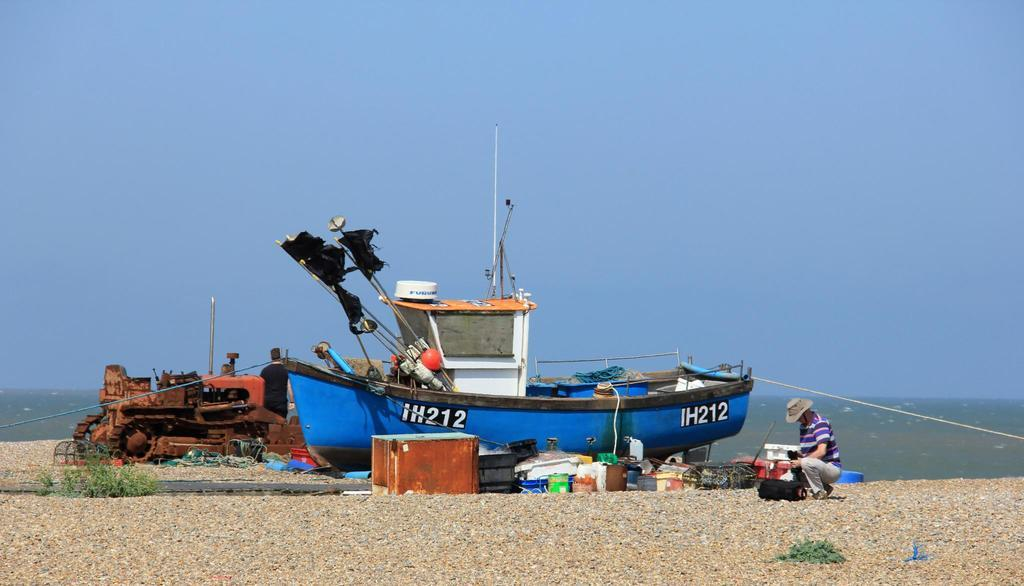What is the main subject of the image? The main subject of the image is a boat. What can be found inside the boat? There are objects inside the boat. What other mode of transportation is present in the image? There is a vehicle in the image. How many people are in the image? There are two people in the image. What is the purpose of the rope in the image? The purpose of the rope in the image is not clear, but it might be used for tying or anchoring the boat. What type of object can be seen in the image, and what color is it? There is a brown box in the image. What is visible on the ground in the image? There are objects on the ground in the image. What is the color of the sky in the image? The sky is blue in color. What type of book can be seen on the sign in the wilderness? There is no book or sign present in the image, and the image does not depict a wilderness setting. 